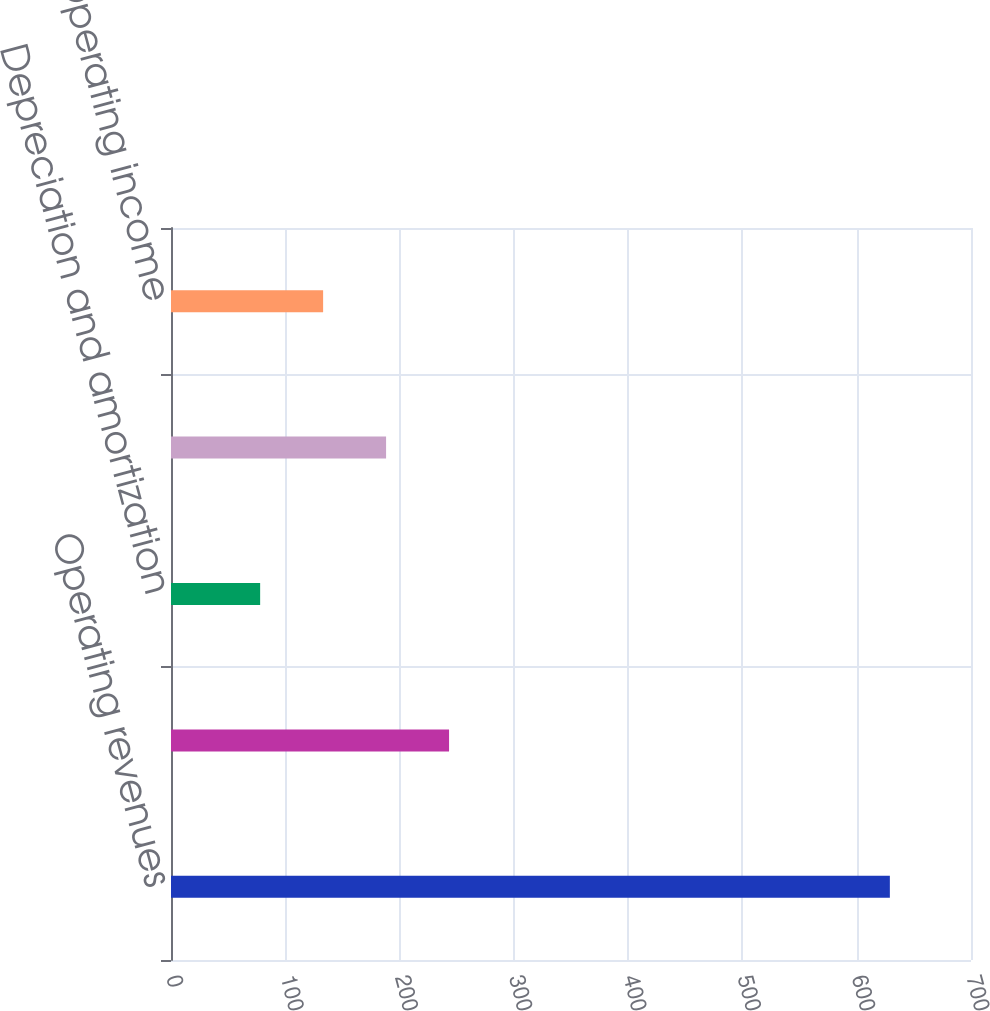Convert chart to OTSL. <chart><loc_0><loc_0><loc_500><loc_500><bar_chart><fcel>Operating revenues<fcel>Other operations and<fcel>Depreciation and amortization<fcel>Taxes other than income taxes<fcel>Operating income<nl><fcel>629<fcel>243.3<fcel>78<fcel>188.2<fcel>133.1<nl></chart> 